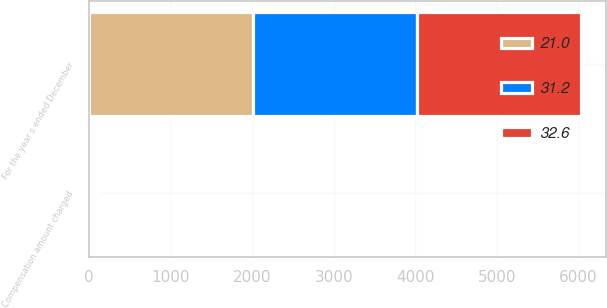Convert chart to OTSL. <chart><loc_0><loc_0><loc_500><loc_500><stacked_bar_chart><ecel><fcel>For the year s ended December<fcel>Compensation amount charged<nl><fcel>31.2<fcel>2013<fcel>32.6<nl><fcel>32.6<fcel>2012<fcel>31.2<nl><fcel>21<fcel>2011<fcel>21<nl></chart> 